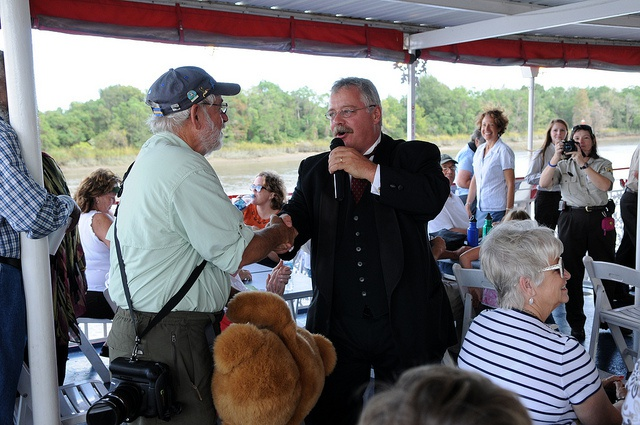Describe the objects in this image and their specific colors. I can see people in lightgray, black, brown, gray, and maroon tones, people in lightgray, darkgray, black, lightblue, and gray tones, people in lightgray, darkgray, gray, and lavender tones, teddy bear in lightgray, maroon, black, and brown tones, and people in lightgray, black, gray, and darkgray tones in this image. 